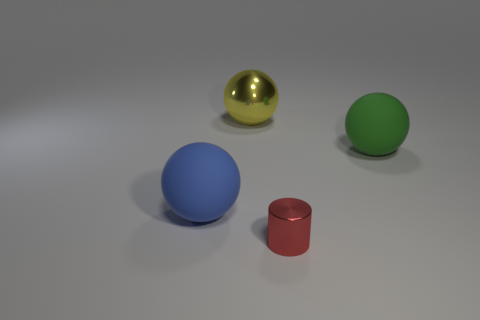Subtract all big blue matte spheres. How many spheres are left? 2 Add 3 small purple rubber spheres. How many objects exist? 7 Subtract all cylinders. How many objects are left? 3 Subtract 0 gray balls. How many objects are left? 4 Subtract all cyan balls. Subtract all yellow cylinders. How many balls are left? 3 Subtract all red cylinders. Subtract all small red metallic things. How many objects are left? 2 Add 1 blue rubber balls. How many blue rubber balls are left? 2 Add 2 big cyan cubes. How many big cyan cubes exist? 2 